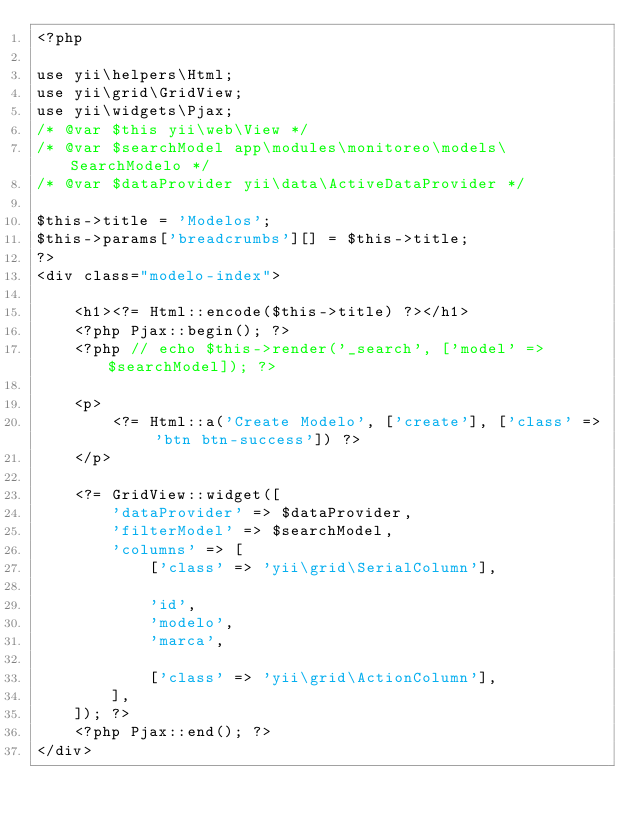<code> <loc_0><loc_0><loc_500><loc_500><_PHP_><?php

use yii\helpers\Html;
use yii\grid\GridView;
use yii\widgets\Pjax;
/* @var $this yii\web\View */
/* @var $searchModel app\modules\monitoreo\models\SearchModelo */
/* @var $dataProvider yii\data\ActiveDataProvider */

$this->title = 'Modelos';
$this->params['breadcrumbs'][] = $this->title;
?>
<div class="modelo-index">

    <h1><?= Html::encode($this->title) ?></h1>
    <?php Pjax::begin(); ?>
    <?php // echo $this->render('_search', ['model' => $searchModel]); ?>

    <p>
        <?= Html::a('Create Modelo', ['create'], ['class' => 'btn btn-success']) ?>
    </p>

    <?= GridView::widget([
        'dataProvider' => $dataProvider,
        'filterModel' => $searchModel,
        'columns' => [
            ['class' => 'yii\grid\SerialColumn'],

            'id',
            'modelo',
            'marca',

            ['class' => 'yii\grid\ActionColumn'],
        ],
    ]); ?>
    <?php Pjax::end(); ?>
</div>
</code> 